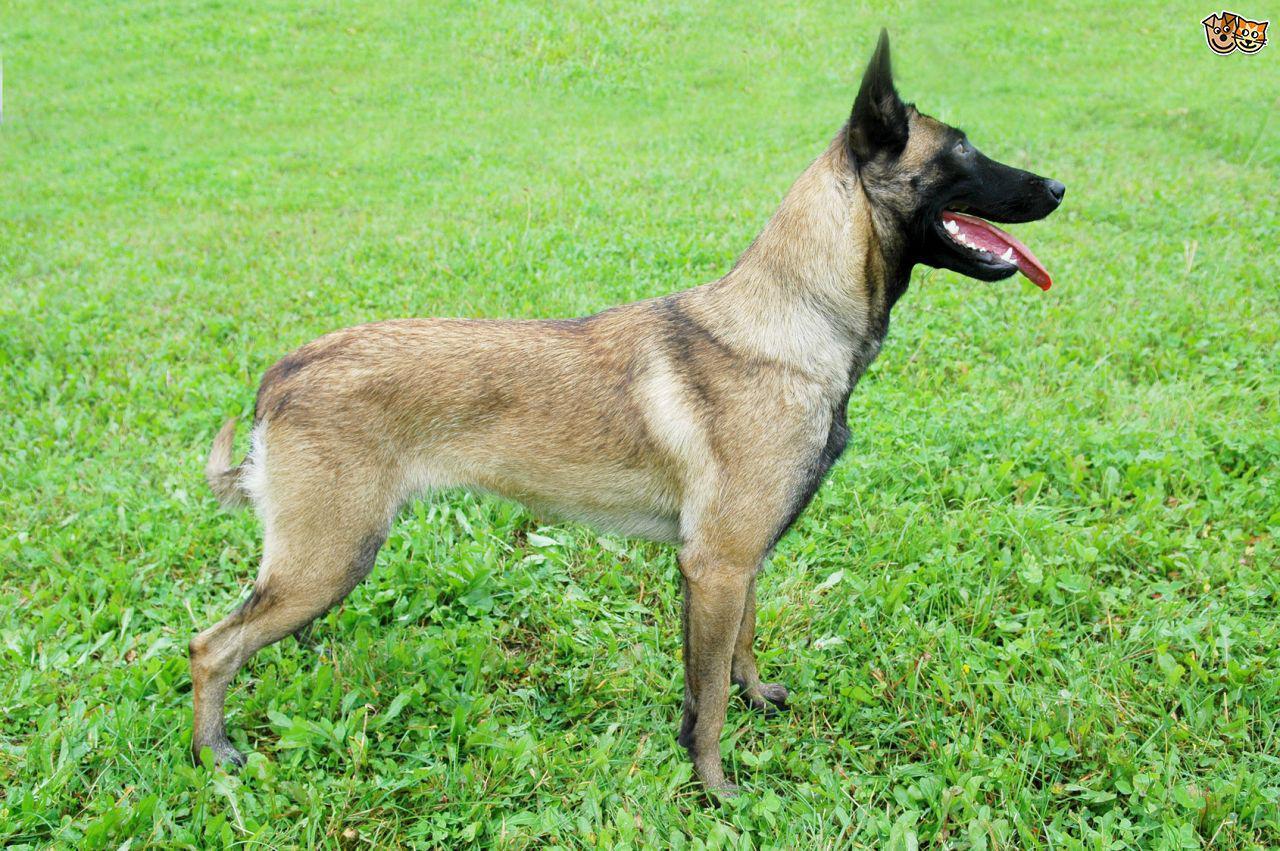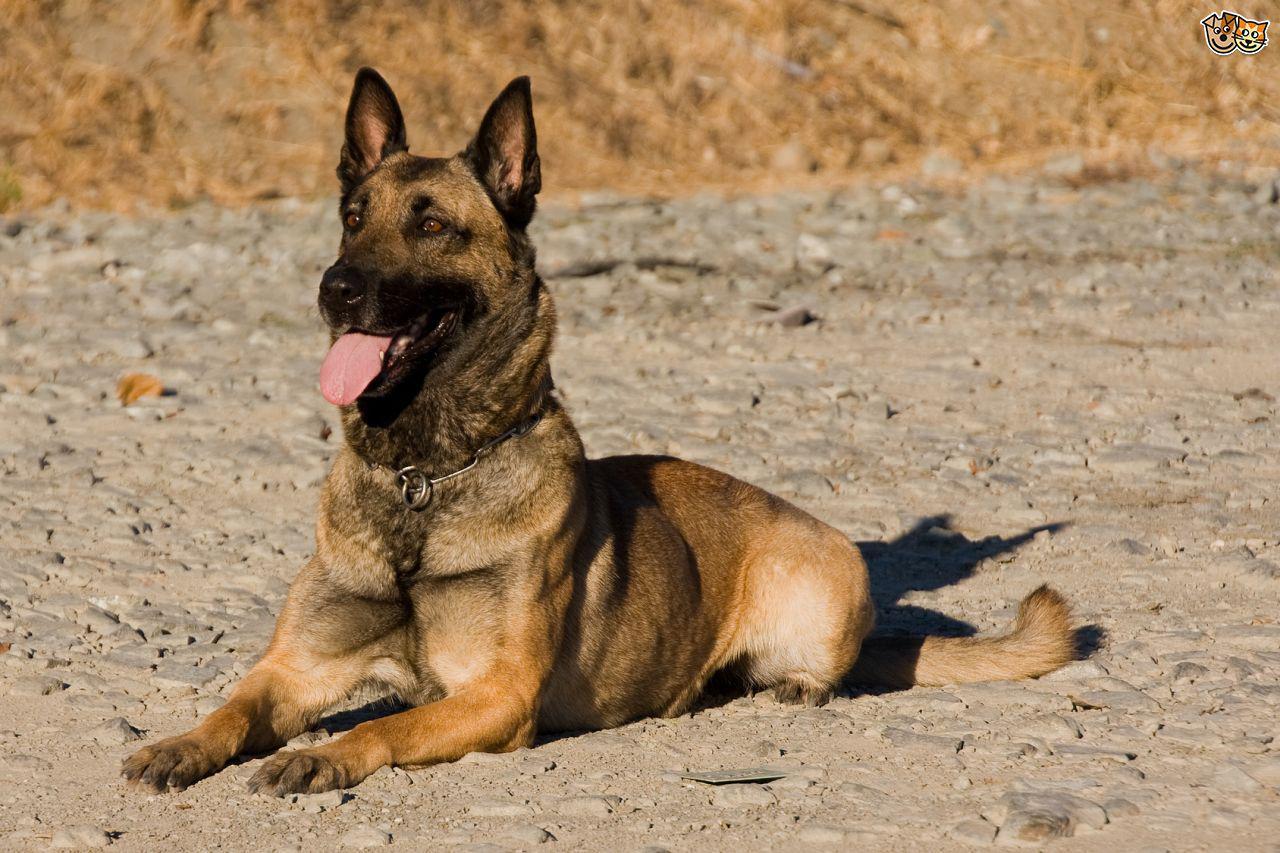The first image is the image on the left, the second image is the image on the right. Analyze the images presented: Is the assertion "There is a dog looking off to the left." valid? Answer yes or no. Yes. 